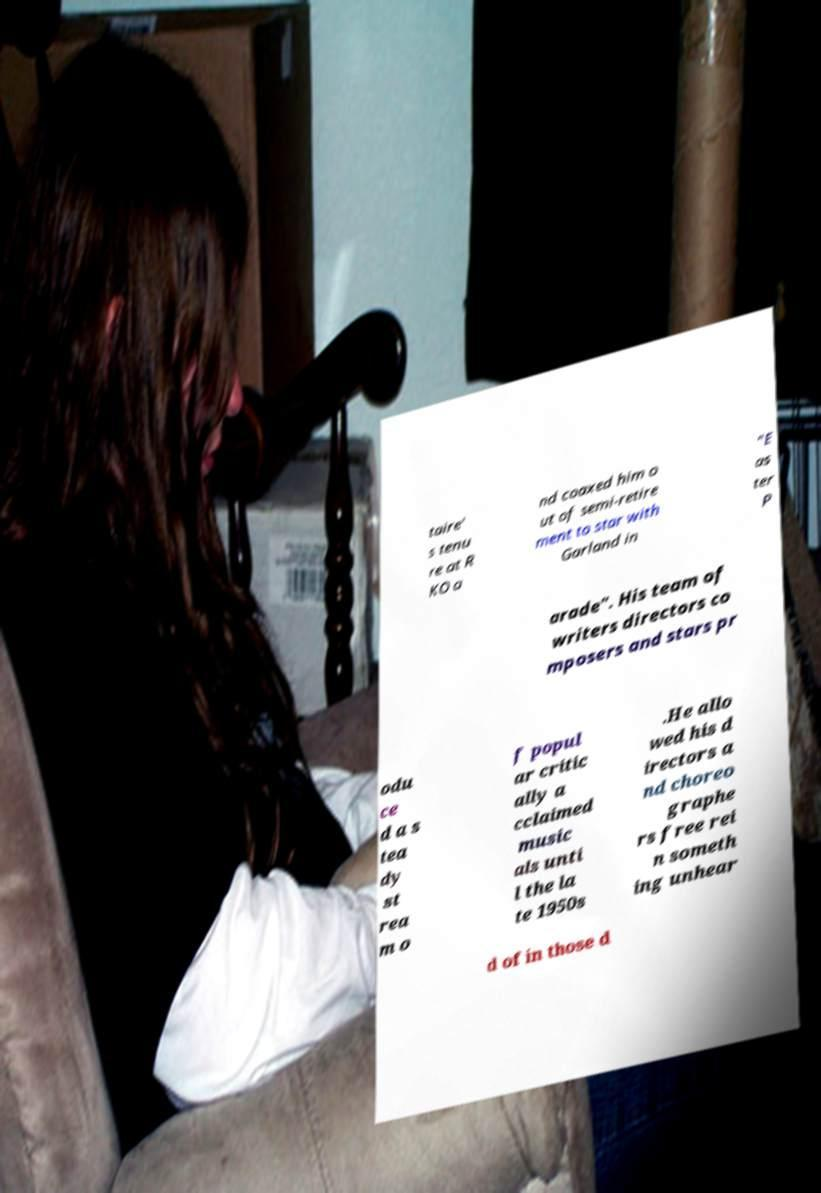There's text embedded in this image that I need extracted. Can you transcribe it verbatim? taire' s tenu re at R KO a nd coaxed him o ut of semi-retire ment to star with Garland in "E as ter P arade". His team of writers directors co mposers and stars pr odu ce d a s tea dy st rea m o f popul ar critic ally a cclaimed music als unti l the la te 1950s .He allo wed his d irectors a nd choreo graphe rs free rei n someth ing unhear d of in those d 